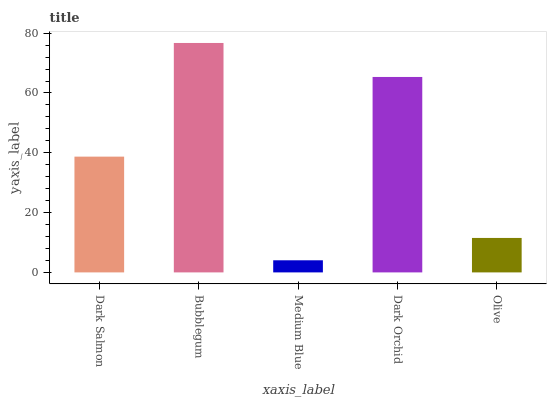Is Bubblegum the minimum?
Answer yes or no. No. Is Medium Blue the maximum?
Answer yes or no. No. Is Bubblegum greater than Medium Blue?
Answer yes or no. Yes. Is Medium Blue less than Bubblegum?
Answer yes or no. Yes. Is Medium Blue greater than Bubblegum?
Answer yes or no. No. Is Bubblegum less than Medium Blue?
Answer yes or no. No. Is Dark Salmon the high median?
Answer yes or no. Yes. Is Dark Salmon the low median?
Answer yes or no. Yes. Is Bubblegum the high median?
Answer yes or no. No. Is Dark Orchid the low median?
Answer yes or no. No. 